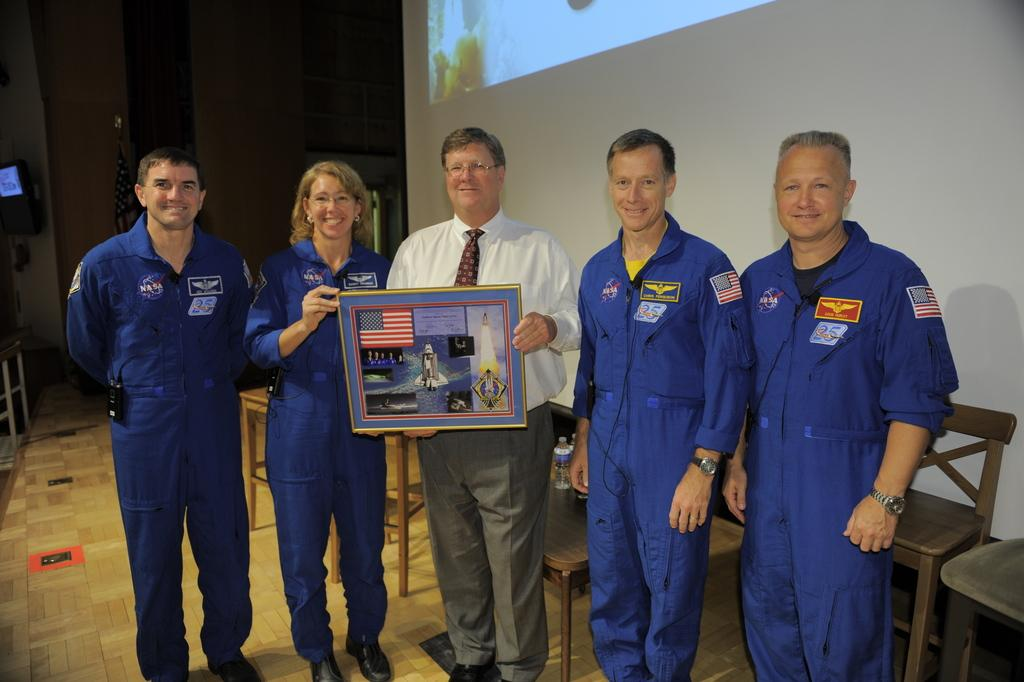How many people are in the image? There is a group of people in the image. Can you describe the attire of some of the people? Four of the people are wearing uniforms. What is one person holding in the image? One person is holding a photo frame. Where is the goose sitting in the image? There is no goose present in the image. What type of reward is being given to the people in the image? There is no indication of a reward being given in the image. 